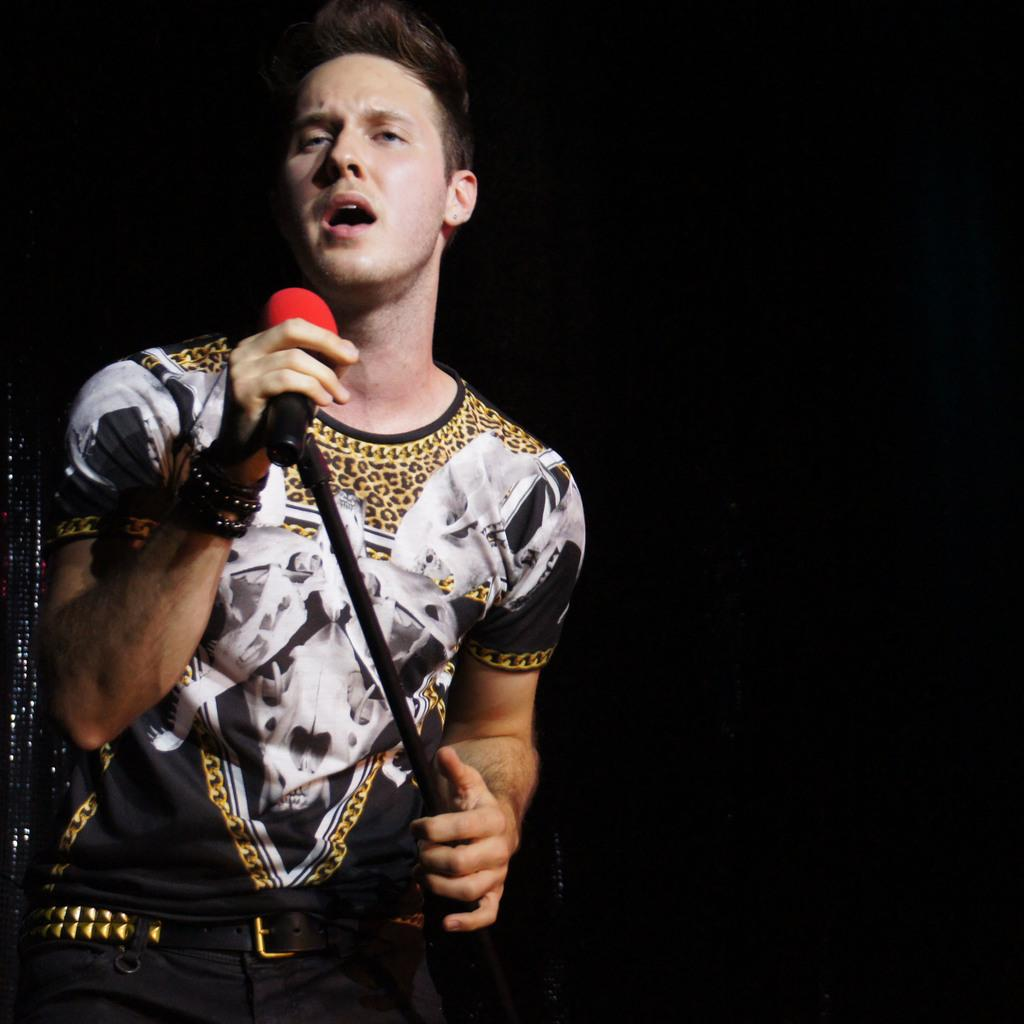What is the person in the image doing? The person is singing into a microphone. What can be inferred about the setting of the image? The scene is on a stage, and the background is dark. When was the image taken? The image was taken during night time. What color are the person's toes in the image? There is no information about the person's toes in the image, so we cannot determine their color. 